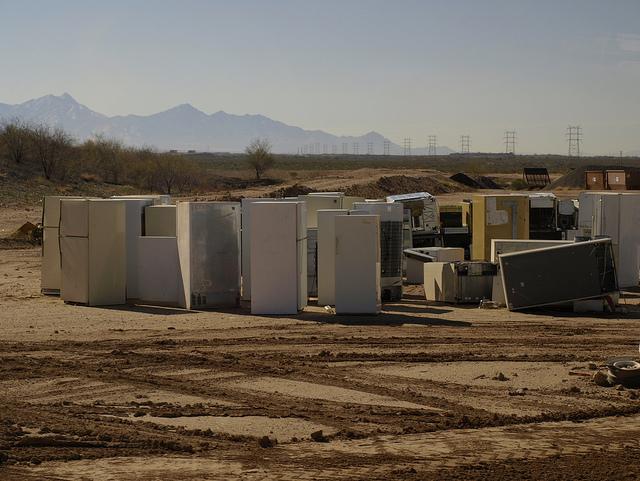Are any of these refrigerators working now?
Keep it brief. No. What city is this?
Quick response, please. None. What number is on the yellow truck?
Give a very brief answer. 0. Based on the color of the dirt has it rained recently?
Write a very short answer. Yes. How is this extremely unsafe?
Keep it brief. Child can get stuck in fridges. 